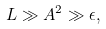Convert formula to latex. <formula><loc_0><loc_0><loc_500><loc_500>L \gg A ^ { 2 } \gg \epsilon ,</formula> 